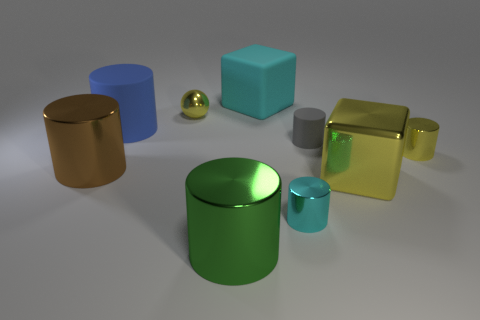Is there a small shiny thing of the same color as the large rubber cube?
Provide a short and direct response. Yes. What is the shape of the gray object that is the same size as the metallic ball?
Your answer should be very brief. Cylinder. What is the color of the metal cylinder that is to the right of the cyan cylinder?
Offer a terse response. Yellow. Are there any yellow metal cubes right of the big cube that is behind the yellow metallic cube?
Offer a very short reply. Yes. What number of things are either yellow metallic things in front of the brown shiny cylinder or shiny balls?
Your response must be concise. 2. The cyan object that is behind the large metal cylinder that is left of the ball is made of what material?
Your answer should be compact. Rubber. Are there an equal number of cyan metal things that are in front of the green cylinder and tiny yellow shiny things that are in front of the blue cylinder?
Offer a terse response. No. What number of objects are either things in front of the big yellow cube or large objects right of the big brown object?
Provide a succinct answer. 5. What is the material of the yellow object that is on the right side of the small cyan object and to the left of the tiny yellow cylinder?
Ensure brevity in your answer.  Metal. How big is the yellow shiny thing left of the cyan object behind the matte object that is on the left side of the large cyan thing?
Offer a terse response. Small. 